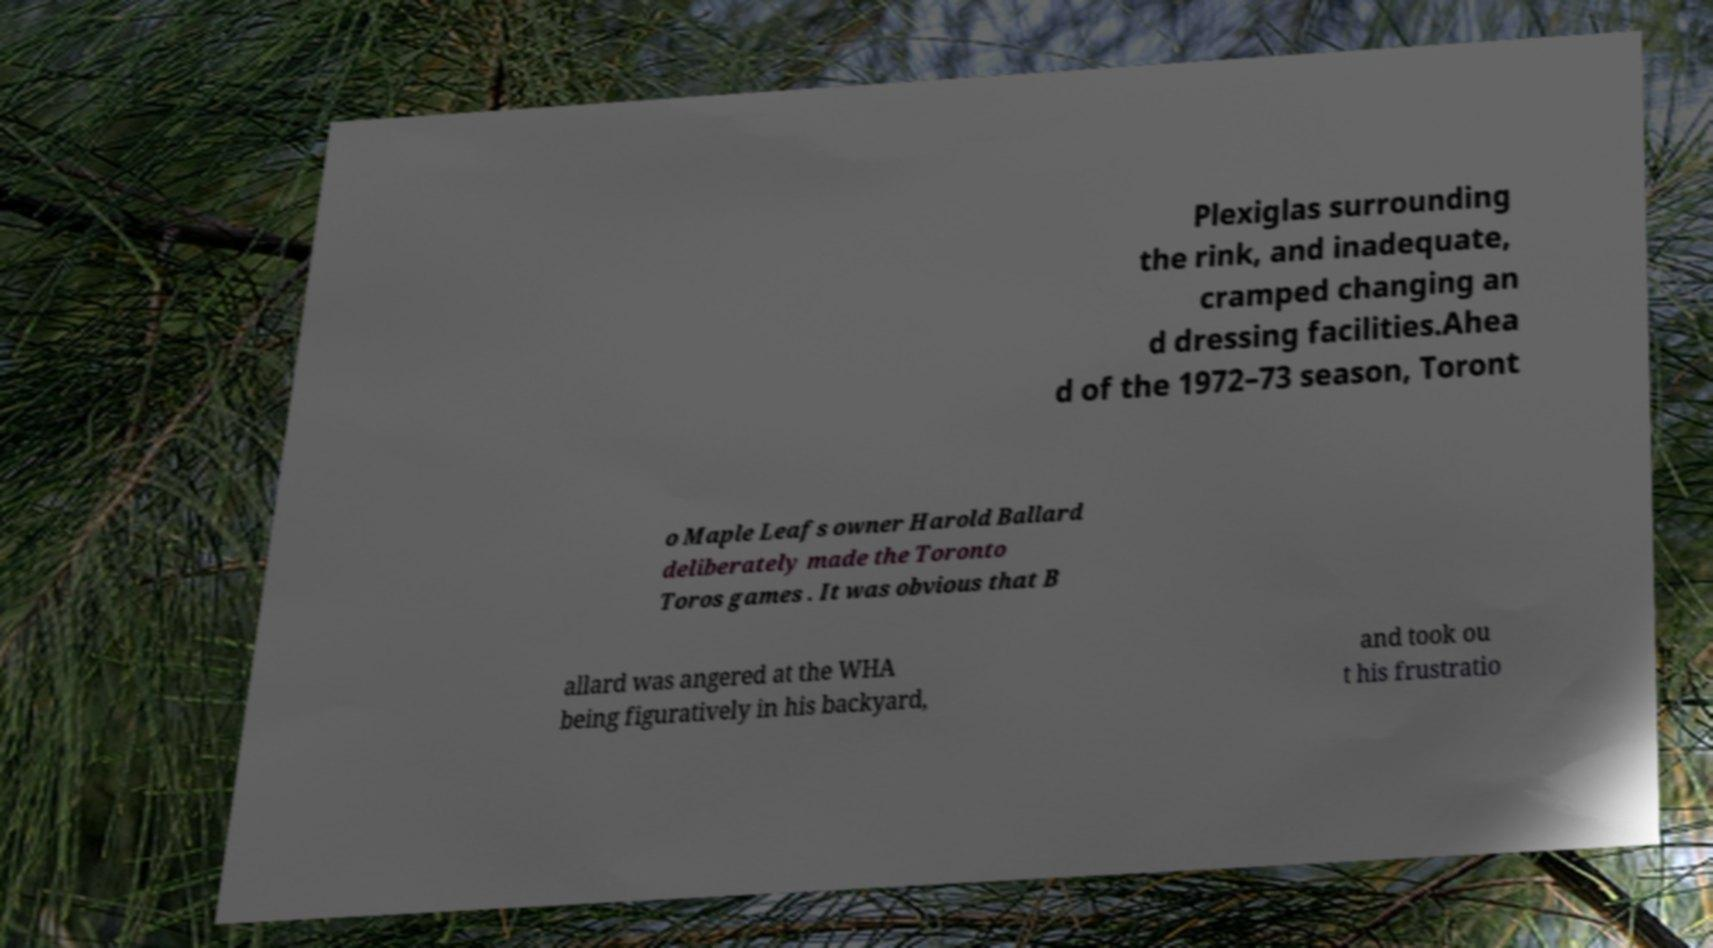Could you extract and type out the text from this image? Plexiglas surrounding the rink, and inadequate, cramped changing an d dressing facilities.Ahea d of the 1972–73 season, Toront o Maple Leafs owner Harold Ballard deliberately made the Toronto Toros games . It was obvious that B allard was angered at the WHA being figuratively in his backyard, and took ou t his frustratio 